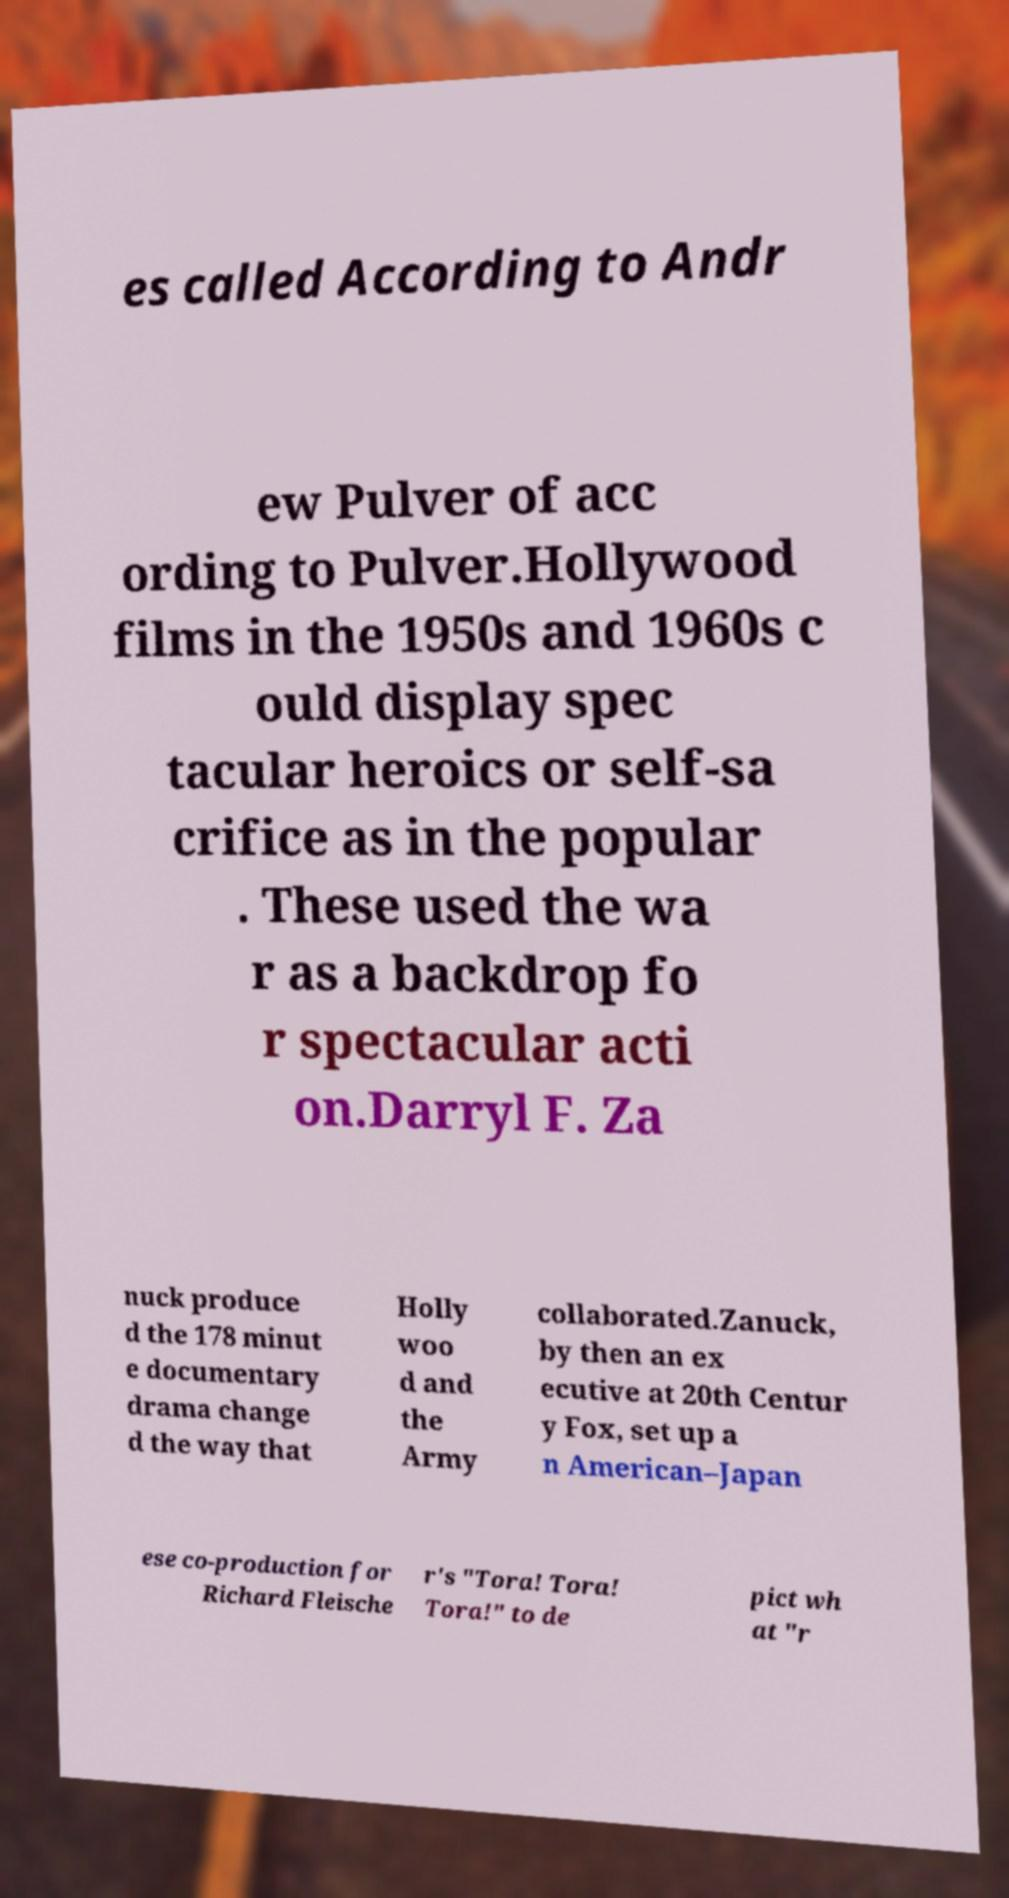Please read and relay the text visible in this image. What does it say? es called According to Andr ew Pulver of acc ording to Pulver.Hollywood films in the 1950s and 1960s c ould display spec tacular heroics or self-sa crifice as in the popular . These used the wa r as a backdrop fo r spectacular acti on.Darryl F. Za nuck produce d the 178 minut e documentary drama change d the way that Holly woo d and the Army collaborated.Zanuck, by then an ex ecutive at 20th Centur y Fox, set up a n American–Japan ese co-production for Richard Fleische r's "Tora! Tora! Tora!" to de pict wh at "r 